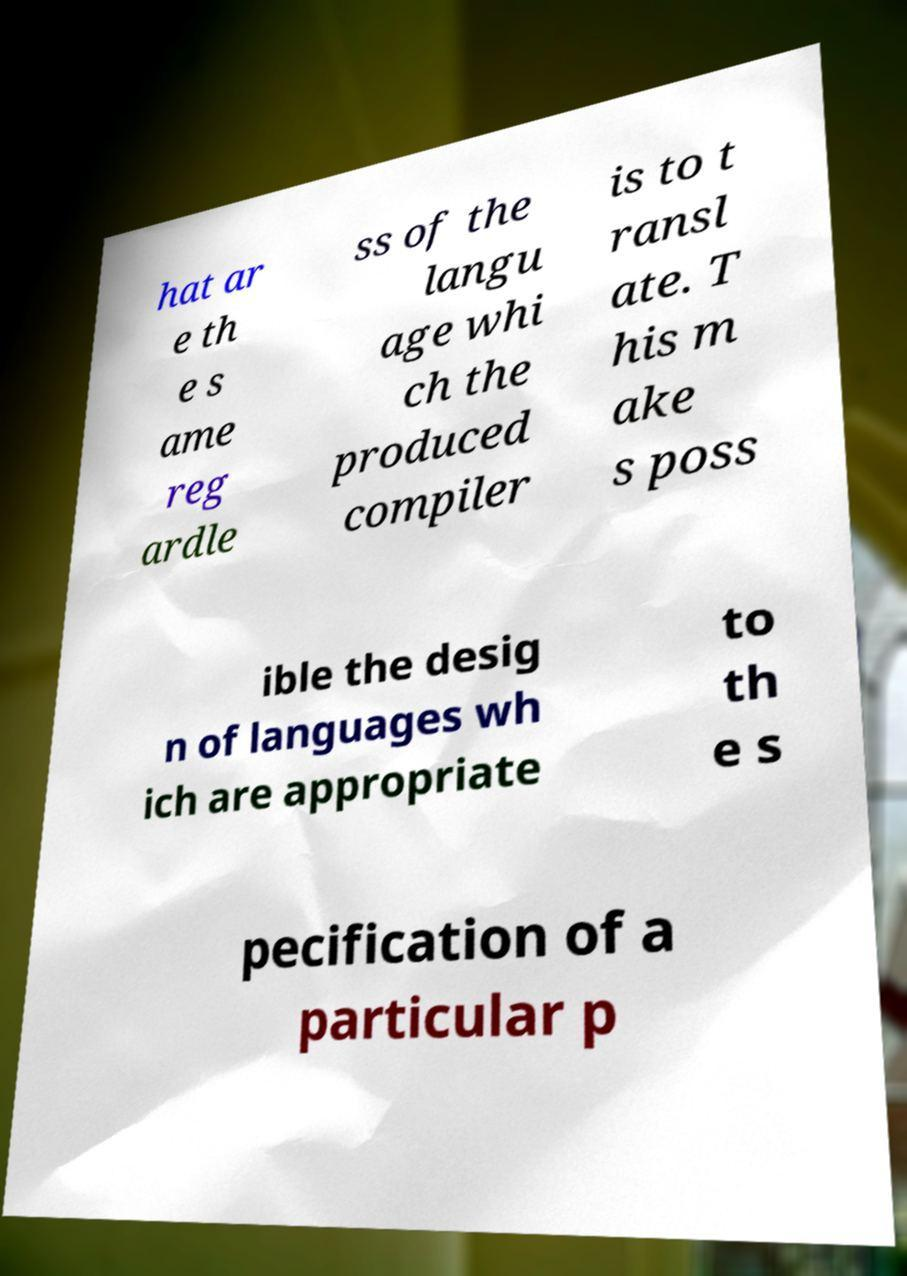I need the written content from this picture converted into text. Can you do that? hat ar e th e s ame reg ardle ss of the langu age whi ch the produced compiler is to t ransl ate. T his m ake s poss ible the desig n of languages wh ich are appropriate to th e s pecification of a particular p 